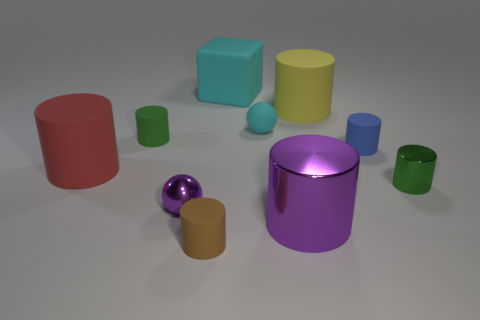Does the small metallic cylinder have the same color as the tiny matte cylinder behind the tiny blue rubber cylinder?
Ensure brevity in your answer.  Yes. Is the color of the small metallic thing left of the large block the same as the big shiny object?
Provide a succinct answer. Yes. What number of other objects are the same color as the tiny matte sphere?
Make the answer very short. 1. Is the large red object made of the same material as the small purple object?
Your answer should be very brief. No. Does the block have the same color as the rubber sphere?
Provide a short and direct response. Yes. What size is the block that is the same color as the matte sphere?
Your answer should be compact. Large. There is a cylinder that is both in front of the small green metallic cylinder and on the left side of the big shiny thing; what is its size?
Provide a short and direct response. Small. Is there a big shiny cylinder of the same color as the metallic sphere?
Your response must be concise. Yes. There is a metallic cylinder that is the same size as the blue rubber cylinder; what is its color?
Keep it short and to the point. Green. There is a large object that is on the left side of the matte cylinder that is in front of the small green cylinder that is in front of the blue cylinder; what is its shape?
Your answer should be very brief. Cylinder. 